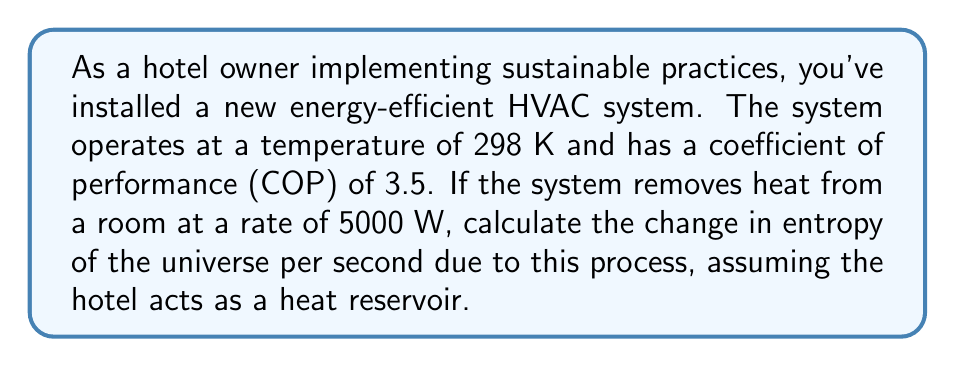Could you help me with this problem? To solve this problem, we'll use concepts from statistical thermodynamics and the Second Law of Thermodynamics. Let's break it down step-by-step:

1) First, recall that the Coefficient of Performance (COP) for a cooling system is defined as:

   $$ COP = \frac{Q_c}{W} $$

   Where $Q_c$ is the heat removed from the cold reservoir (the room) and $W$ is the work done by the system.

2) We're given that $COP = 3.5$ and $Q_c = 5000 W$. Let's calculate the work done:

   $$ 3.5 = \frac{5000}{W} $$
   $$ W = \frac{5000}{3.5} = 1428.57 W $$

3) The heat released to the hot reservoir (the environment) is:

   $$ Q_h = Q_c + W = 5000 + 1428.57 = 6428.57 W $$

4) Now, we can calculate the entropy change of each component:

   a) For the room (cold reservoir):
      $$ \Delta S_c = -\frac{Q_c}{T} = -\frac{5000}{298} = -16.78 W/K $$

   b) For the environment (hot reservoir):
      $$ \Delta S_h = \frac{Q_h}{T} = \frac{6428.57}{298} = 21.57 W/K $$

5) The total entropy change of the universe is the sum of these:

   $$ \Delta S_{universe} = \Delta S_c + \Delta S_h = -16.78 + 21.57 = 4.79 W/K $$

This positive value indicates that the entropy of the universe is increasing, consistent with the Second Law of Thermodynamics.
Answer: 4.79 W/K 